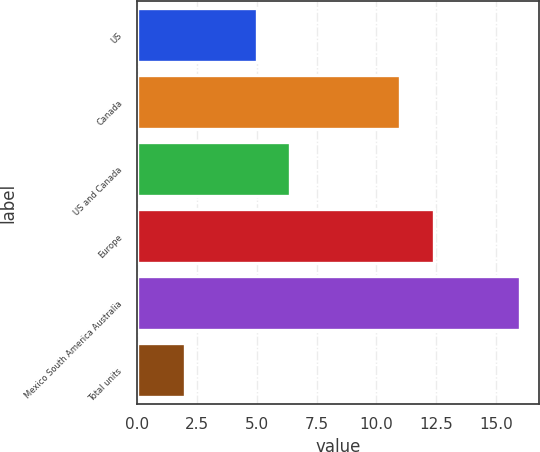Convert chart. <chart><loc_0><loc_0><loc_500><loc_500><bar_chart><fcel>US<fcel>Canada<fcel>US and Canada<fcel>Europe<fcel>Mexico South America Australia<fcel>Total units<nl><fcel>5<fcel>11<fcel>6.4<fcel>12.4<fcel>16<fcel>2<nl></chart> 